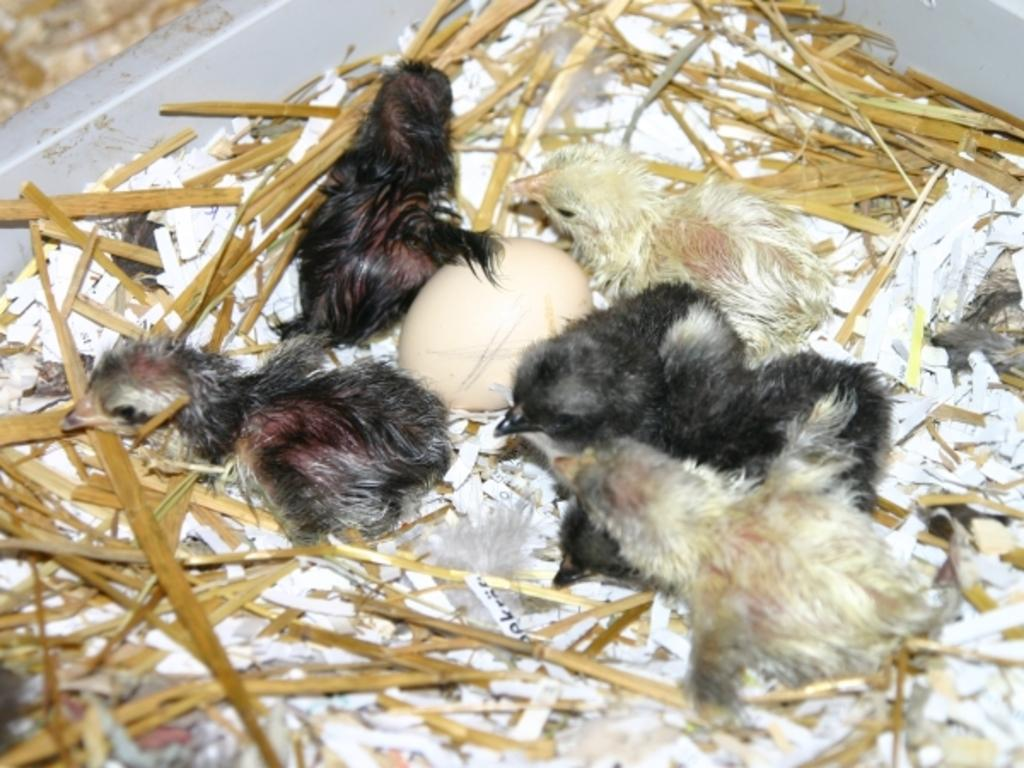What type of animals can be seen in the image? There are birds in the image. What is the color of the birds in the image? The birds are black and white in color. What other object can be seen in the image besides the birds? There is an egg in the image. What type of vegetation is present in the image? There is dried grass in the image. What type of detail can be seen on the birds' wings in the image? There is no specific detail mentioned on the birds' wings in the provided facts, so it cannot be determined from the image. 